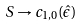Convert formula to latex. <formula><loc_0><loc_0><loc_500><loc_500>S \rightarrow c _ { 1 , 0 } ( \hat { \epsilon } )</formula> 